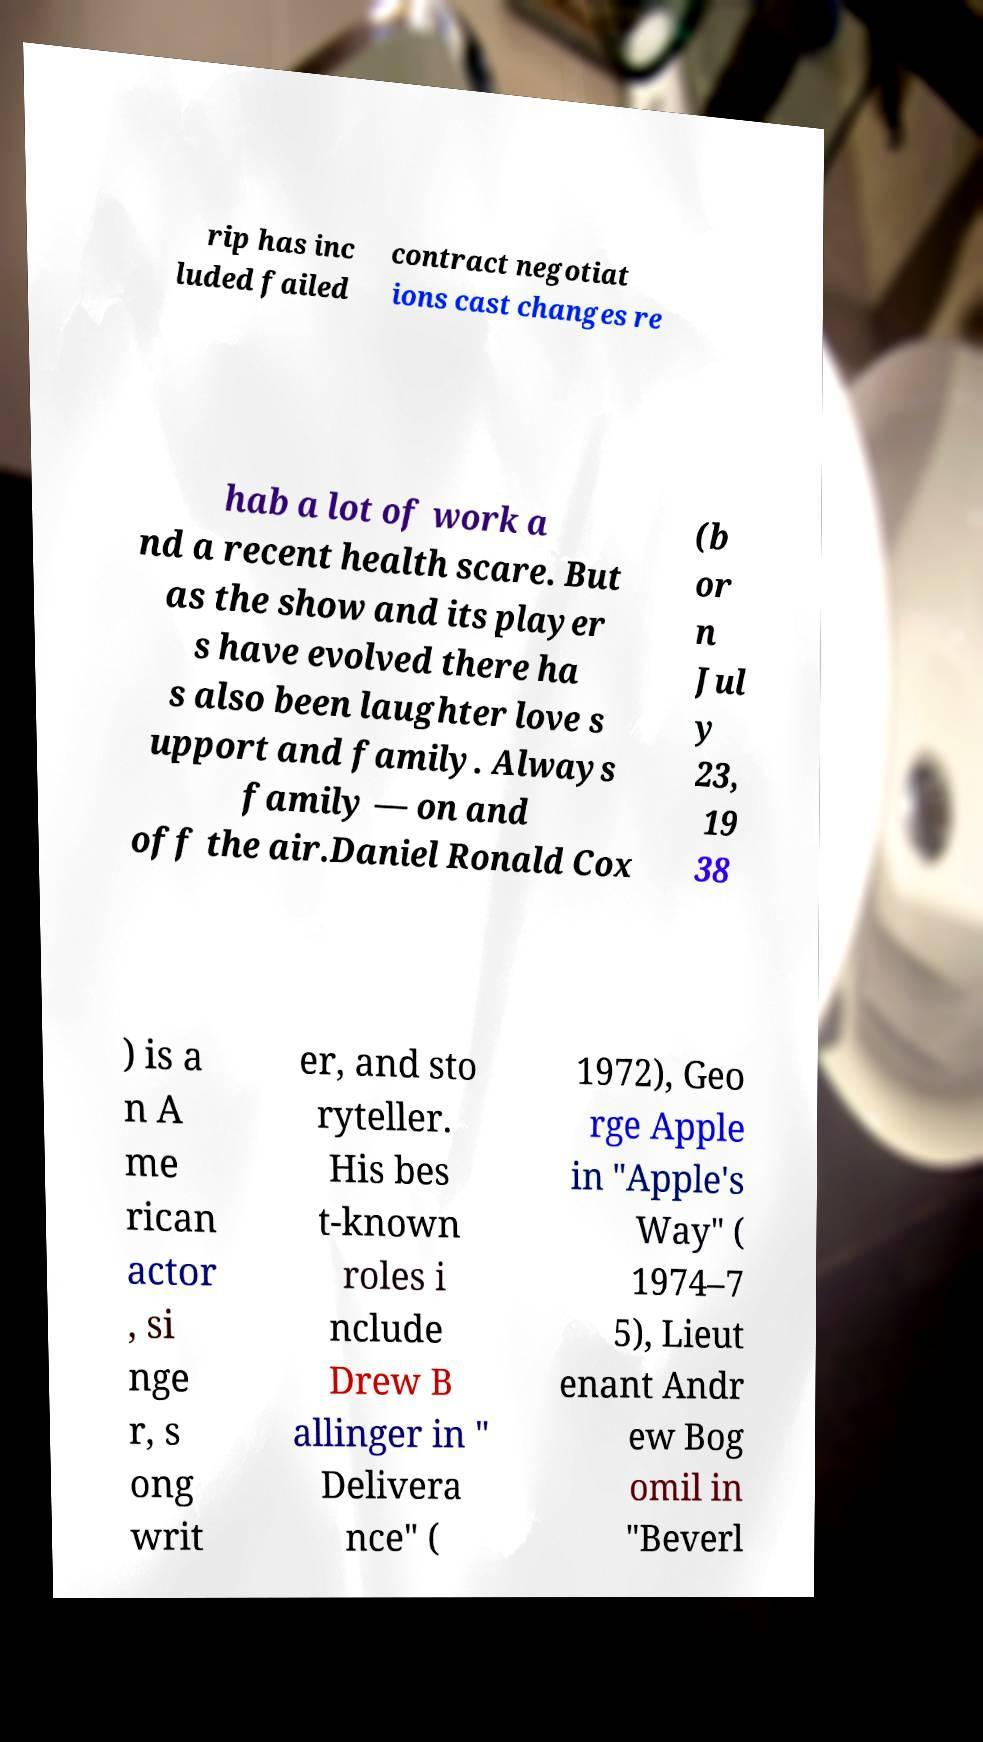Please identify and transcribe the text found in this image. rip has inc luded failed contract negotiat ions cast changes re hab a lot of work a nd a recent health scare. But as the show and its player s have evolved there ha s also been laughter love s upport and family. Always family — on and off the air.Daniel Ronald Cox (b or n Jul y 23, 19 38 ) is a n A me rican actor , si nge r, s ong writ er, and sto ryteller. His bes t-known roles i nclude Drew B allinger in " Delivera nce" ( 1972), Geo rge Apple in "Apple's Way" ( 1974–7 5), Lieut enant Andr ew Bog omil in "Beverl 